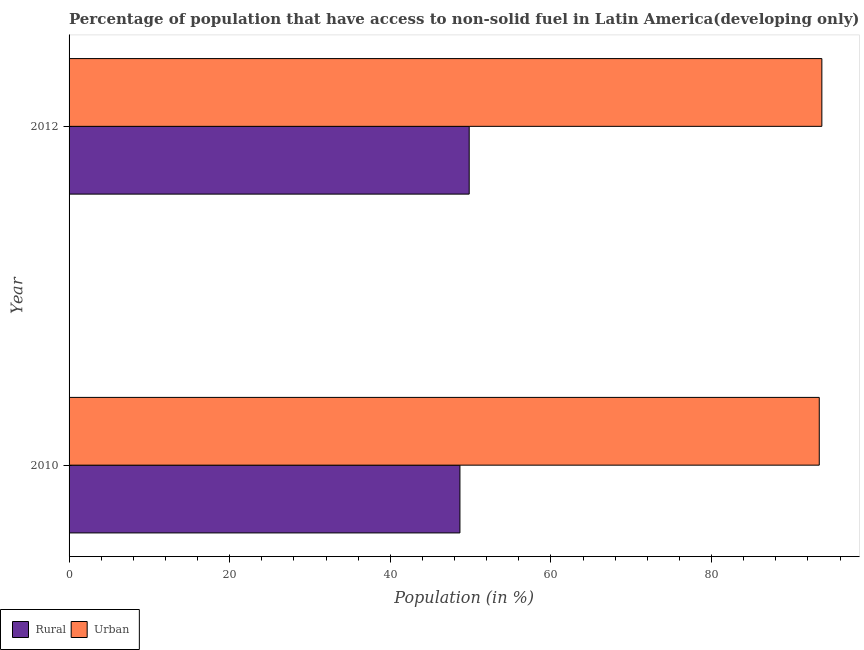How many different coloured bars are there?
Your response must be concise. 2. How many groups of bars are there?
Give a very brief answer. 2. Are the number of bars per tick equal to the number of legend labels?
Provide a succinct answer. Yes. How many bars are there on the 2nd tick from the bottom?
Provide a succinct answer. 2. What is the label of the 1st group of bars from the top?
Your answer should be very brief. 2012. In how many cases, is the number of bars for a given year not equal to the number of legend labels?
Your response must be concise. 0. What is the rural population in 2010?
Offer a very short reply. 48.67. Across all years, what is the maximum rural population?
Make the answer very short. 49.82. Across all years, what is the minimum urban population?
Your answer should be compact. 93.4. In which year was the rural population maximum?
Your response must be concise. 2012. What is the total urban population in the graph?
Offer a terse response. 187.13. What is the difference between the rural population in 2010 and that in 2012?
Give a very brief answer. -1.15. What is the difference between the urban population in 2010 and the rural population in 2012?
Your answer should be compact. 43.59. What is the average urban population per year?
Your answer should be very brief. 93.57. In the year 2012, what is the difference between the urban population and rural population?
Provide a succinct answer. 43.91. In how many years, is the rural population greater than 68 %?
Give a very brief answer. 0. In how many years, is the urban population greater than the average urban population taken over all years?
Your response must be concise. 1. What does the 2nd bar from the top in 2012 represents?
Give a very brief answer. Rural. What does the 2nd bar from the bottom in 2010 represents?
Ensure brevity in your answer.  Urban. How many bars are there?
Your answer should be very brief. 4. What is the difference between two consecutive major ticks on the X-axis?
Your response must be concise. 20. Does the graph contain grids?
Keep it short and to the point. No. How are the legend labels stacked?
Provide a succinct answer. Horizontal. What is the title of the graph?
Provide a short and direct response. Percentage of population that have access to non-solid fuel in Latin America(developing only). What is the label or title of the X-axis?
Ensure brevity in your answer.  Population (in %). What is the Population (in %) in Rural in 2010?
Offer a terse response. 48.67. What is the Population (in %) in Urban in 2010?
Give a very brief answer. 93.4. What is the Population (in %) of Rural in 2012?
Your response must be concise. 49.82. What is the Population (in %) of Urban in 2012?
Your answer should be very brief. 93.73. Across all years, what is the maximum Population (in %) of Rural?
Your answer should be very brief. 49.82. Across all years, what is the maximum Population (in %) of Urban?
Make the answer very short. 93.73. Across all years, what is the minimum Population (in %) of Rural?
Ensure brevity in your answer.  48.67. Across all years, what is the minimum Population (in %) of Urban?
Offer a terse response. 93.4. What is the total Population (in %) of Rural in the graph?
Offer a terse response. 98.48. What is the total Population (in %) in Urban in the graph?
Provide a succinct answer. 187.13. What is the difference between the Population (in %) of Rural in 2010 and that in 2012?
Offer a terse response. -1.15. What is the difference between the Population (in %) in Urban in 2010 and that in 2012?
Offer a very short reply. -0.32. What is the difference between the Population (in %) in Rural in 2010 and the Population (in %) in Urban in 2012?
Your answer should be very brief. -45.06. What is the average Population (in %) in Rural per year?
Your answer should be very brief. 49.24. What is the average Population (in %) in Urban per year?
Give a very brief answer. 93.57. In the year 2010, what is the difference between the Population (in %) of Rural and Population (in %) of Urban?
Your answer should be compact. -44.74. In the year 2012, what is the difference between the Population (in %) of Rural and Population (in %) of Urban?
Your answer should be compact. -43.91. What is the ratio of the Population (in %) of Rural in 2010 to that in 2012?
Ensure brevity in your answer.  0.98. What is the ratio of the Population (in %) of Urban in 2010 to that in 2012?
Make the answer very short. 1. What is the difference between the highest and the second highest Population (in %) of Rural?
Provide a short and direct response. 1.15. What is the difference between the highest and the second highest Population (in %) in Urban?
Your response must be concise. 0.32. What is the difference between the highest and the lowest Population (in %) of Rural?
Your answer should be very brief. 1.15. What is the difference between the highest and the lowest Population (in %) of Urban?
Give a very brief answer. 0.32. 